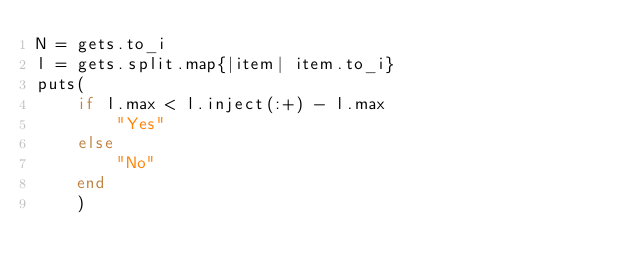<code> <loc_0><loc_0><loc_500><loc_500><_Ruby_>N = gets.to_i
l = gets.split.map{|item| item.to_i}
puts(
    if l.max < l.inject(:+) - l.max
        "Yes"
    else
        "No"
    end
    )</code> 